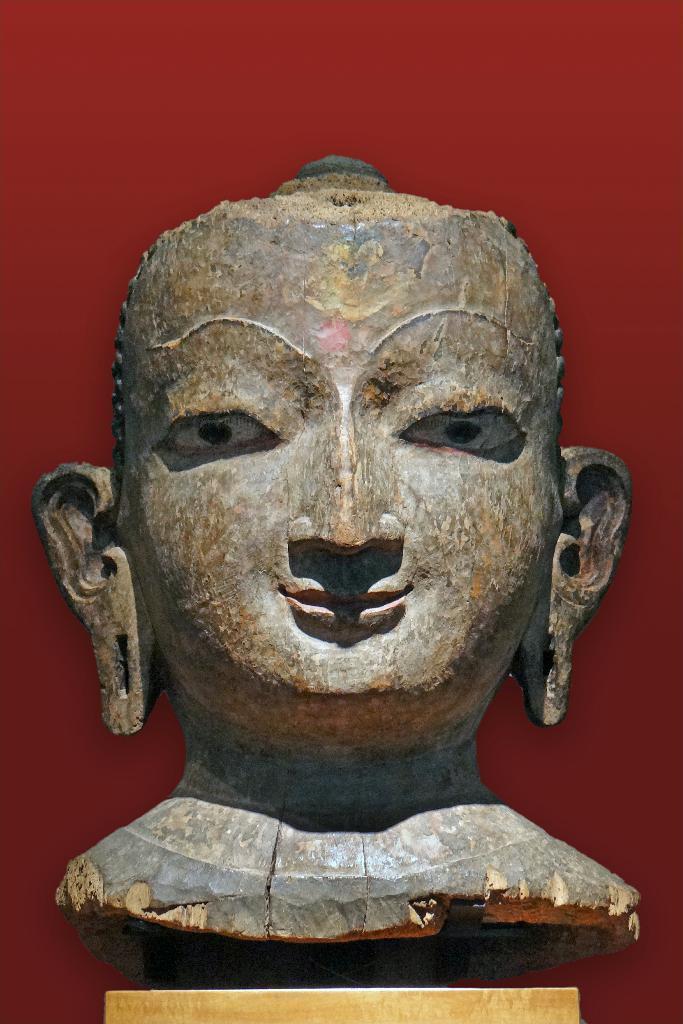Please provide a concise description of this image. In this image I can see the statue of the person's face. And there is a red color background. 